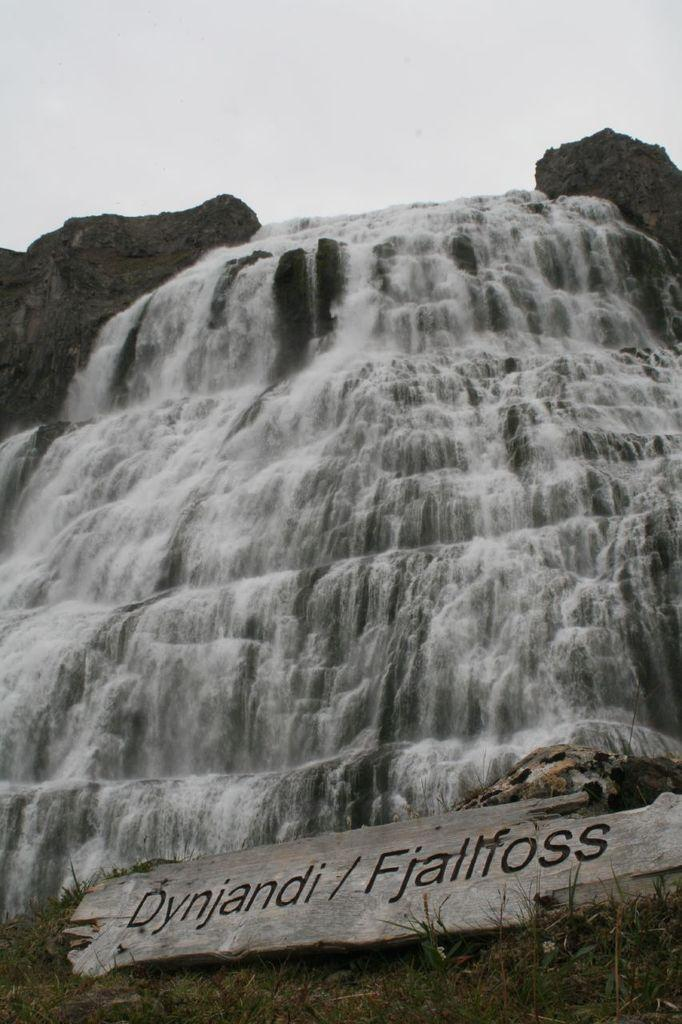What is the color scheme of the image? The image is black and white. What natural feature can be seen in the image? There is a waterfall in the image. What is visible above the waterfall? The sky is visible above the waterfall. What is located in the front of the image? There is a board with text on it in the front of the image. How many sticks are being used by the waterfall in the image? There are no sticks present in the image; it features a waterfall and a board with text. What type of behavior can be observed in the waterfall in the image? The waterfall is a natural feature and does not exhibit behavior; it is simply flowing water. 